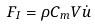Convert formula to latex. <formula><loc_0><loc_0><loc_500><loc_500>F _ { I } = \rho C _ { m } V \dot { u }</formula> 